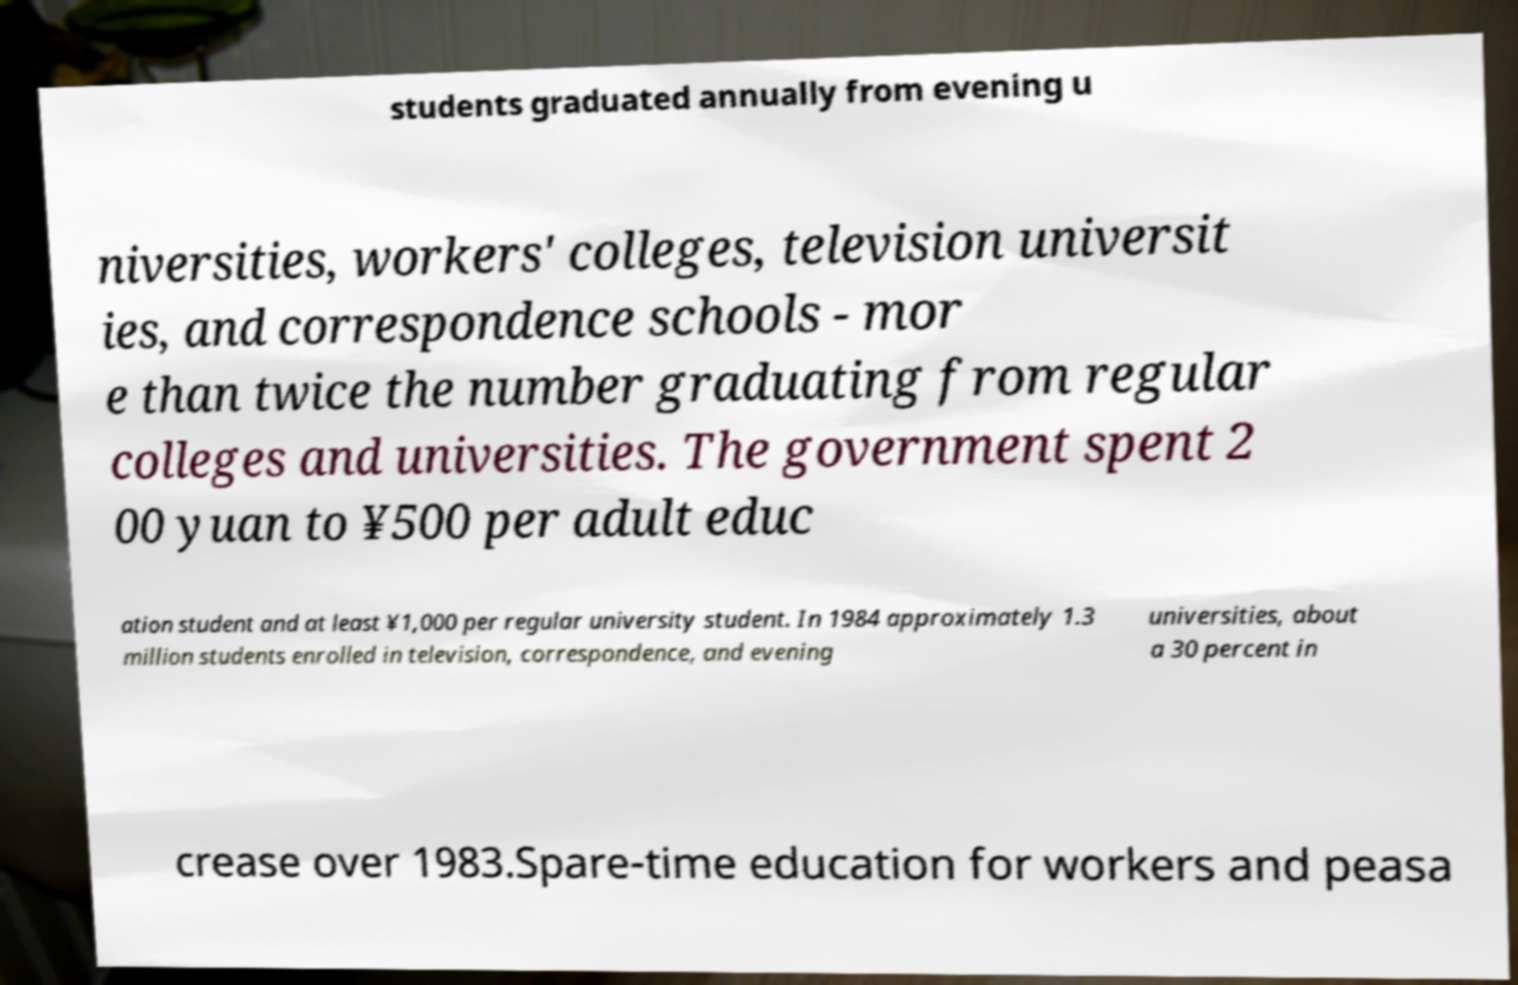Please read and relay the text visible in this image. What does it say? students graduated annually from evening u niversities, workers' colleges, television universit ies, and correspondence schools - mor e than twice the number graduating from regular colleges and universities. The government spent 2 00 yuan to ¥500 per adult educ ation student and at least ¥1,000 per regular university student. In 1984 approximately 1.3 million students enrolled in television, correspondence, and evening universities, about a 30 percent in crease over 1983.Spare-time education for workers and peasa 